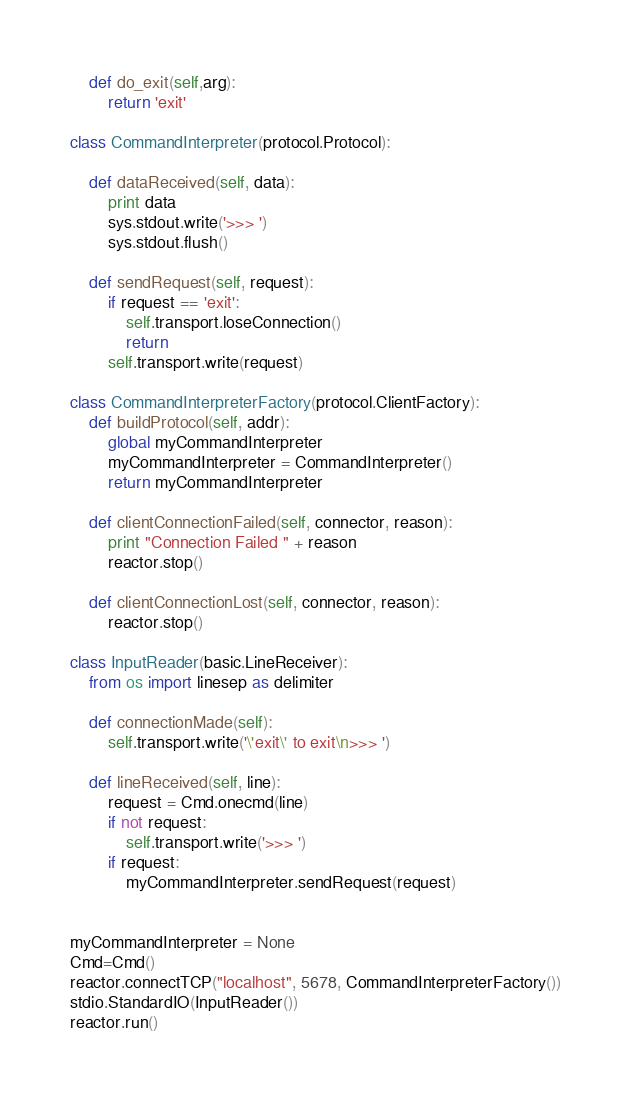Convert code to text. <code><loc_0><loc_0><loc_500><loc_500><_Python_>
    def do_exit(self,arg):
        return 'exit'

class CommandInterpreter(protocol.Protocol):

    def dataReceived(self, data):
        print data
        sys.stdout.write('>>> ')
        sys.stdout.flush()

    def sendRequest(self, request):
        if request == 'exit':
            self.transport.loseConnection()
            return
        self.transport.write(request)

class CommandInterpreterFactory(protocol.ClientFactory):
    def buildProtocol(self, addr):
        global myCommandInterpreter
        myCommandInterpreter = CommandInterpreter()
        return myCommandInterpreter

    def clientConnectionFailed(self, connector, reason):
        print "Connection Failed " + reason
        reactor.stop()

    def clientConnectionLost(self, connector, reason):
        reactor.stop()

class InputReader(basic.LineReceiver):
    from os import linesep as delimiter

    def connectionMade(self):
        self.transport.write('\'exit\' to exit\n>>> ')

    def lineReceived(self, line):
        request = Cmd.onecmd(line)
        if not request:
            self.transport.write('>>> ')
        if request:
            myCommandInterpreter.sendRequest(request)


myCommandInterpreter = None
Cmd=Cmd()
reactor.connectTCP("localhost", 5678, CommandInterpreterFactory())
stdio.StandardIO(InputReader())
reactor.run()
</code> 